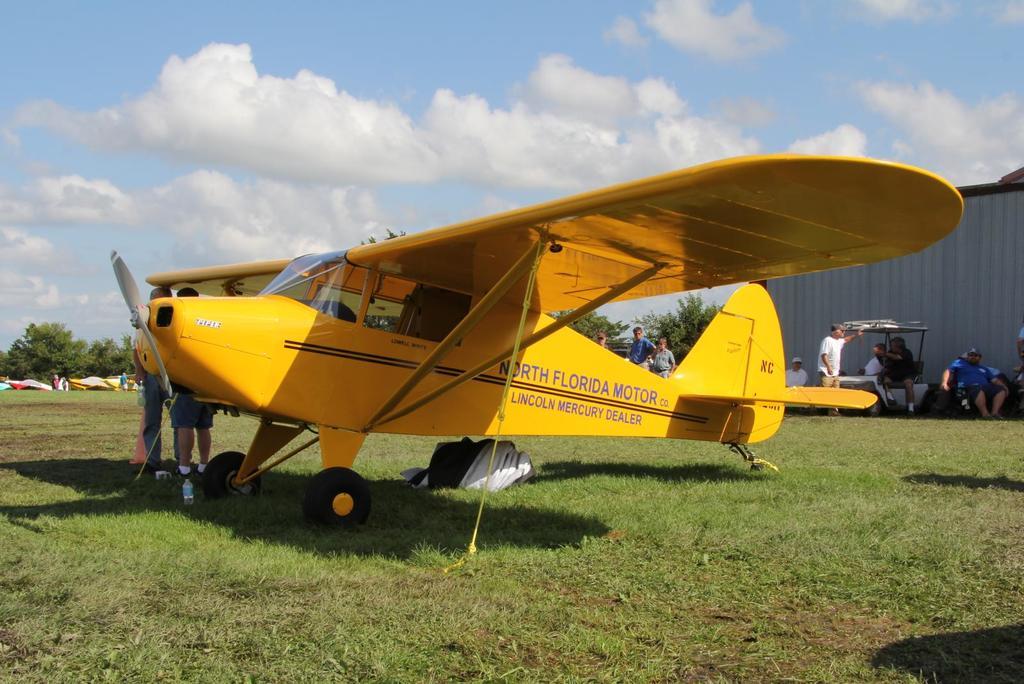What does the plane say?
Offer a very short reply. North florida motor. 